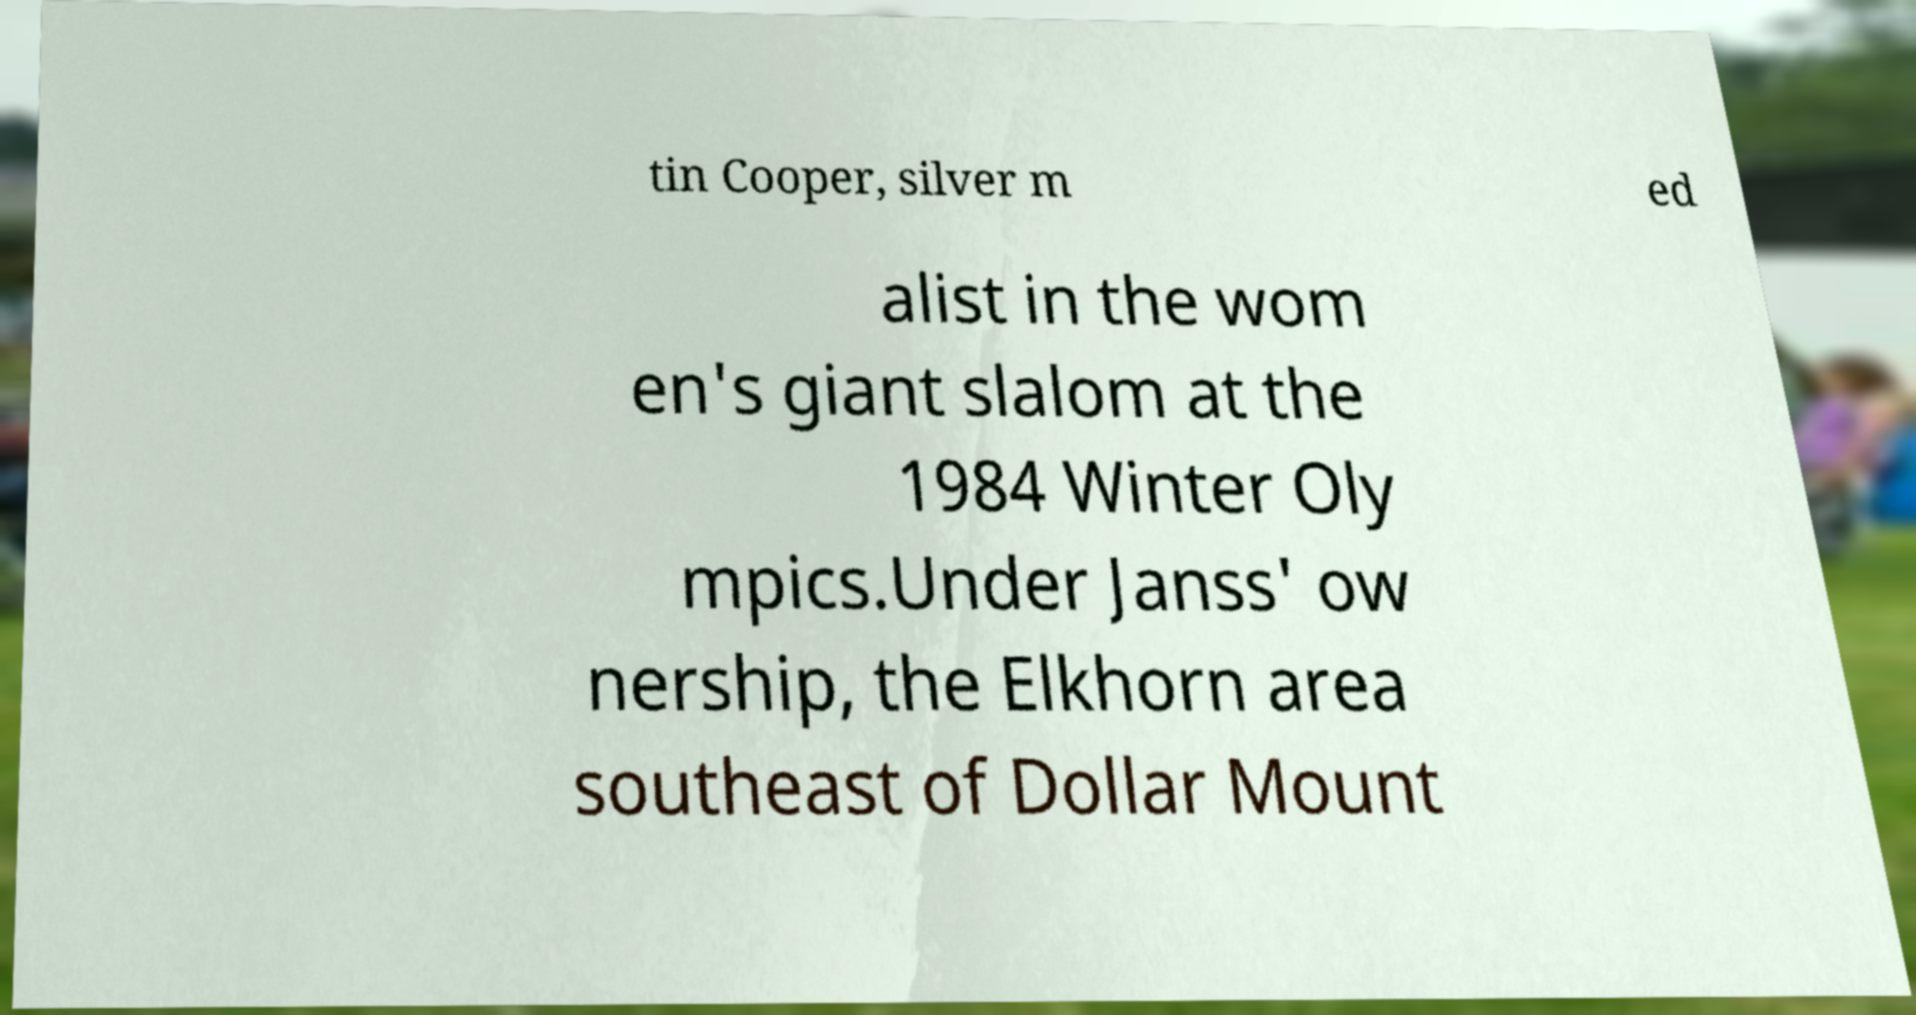There's text embedded in this image that I need extracted. Can you transcribe it verbatim? tin Cooper, silver m ed alist in the wom en's giant slalom at the 1984 Winter Oly mpics.Under Janss' ow nership, the Elkhorn area southeast of Dollar Mount 